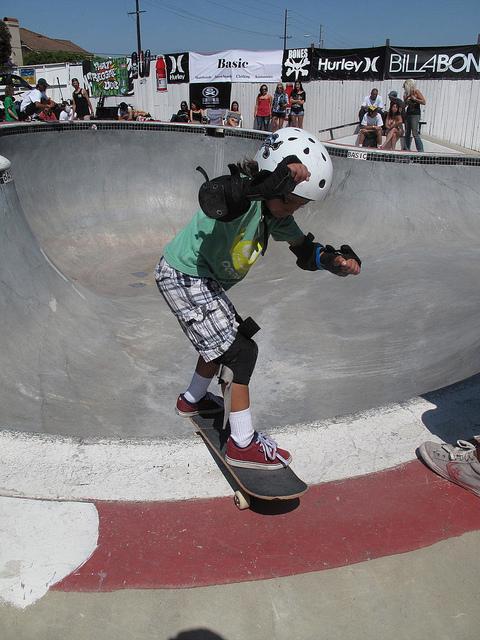What color are the boy's shoes?
Keep it brief. Red. Why does he have a helmet on?
Short answer required. Safety. Does this young man have on proper safety equipment for the sport?
Keep it brief. Yes. Who are two of the sponsors of the event?
Answer briefly. Hurley and billabong. 